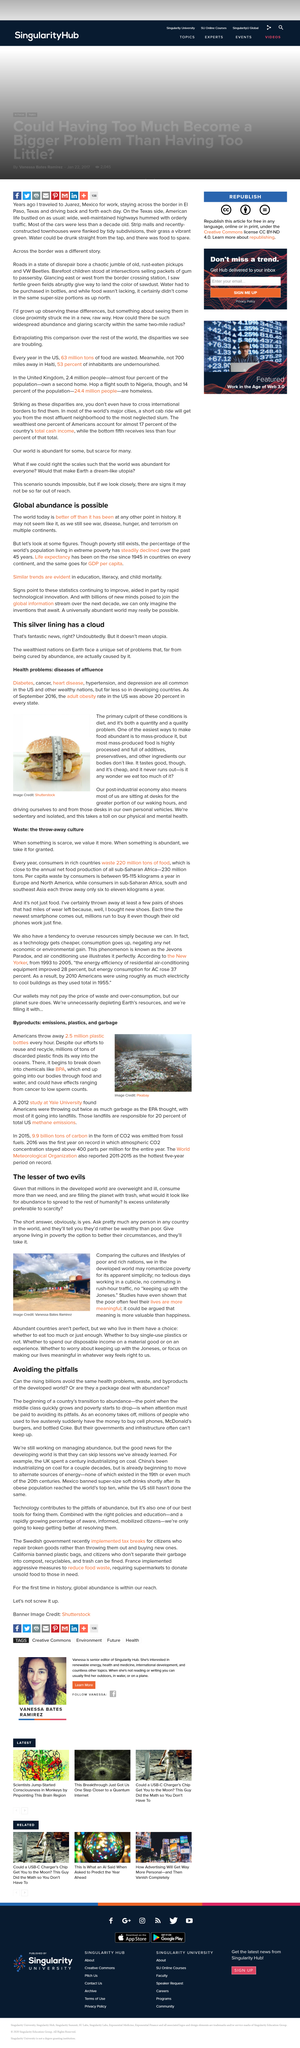Identify some key points in this picture. It is common for people in the developed world to romanticize poverty, viewing it as a desirable and exotic lifestyle. Rich countries waste approximately 220 million tons of food per year, which is equivalent to the weight of nearly 2,200 Eiffel Towers. Is waste one of the pitfalls to be avoided? Yes, it is. When something is abundant, we tend to take it for granted instead of appreciating its value. Yes, discarded plastic both results in plastic finding its way into oceans and causing methane emissions. 